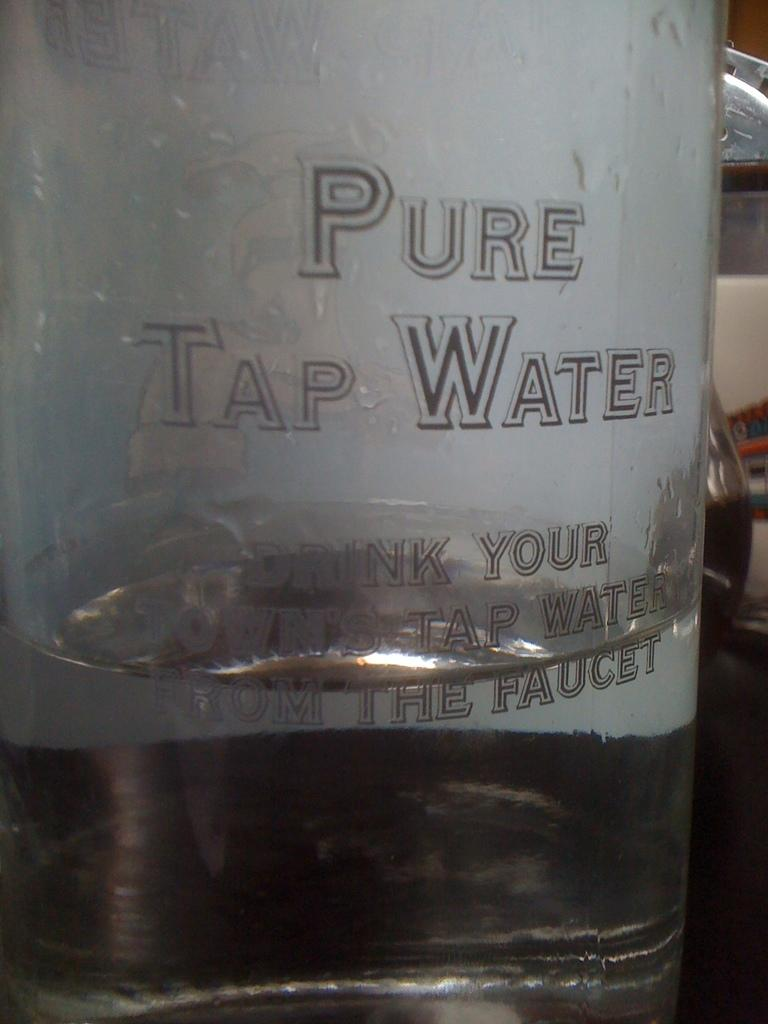What object can be seen in the image? There is a bottle in the image. What is inside the bottle? There is water in the bottle. How many yaks are present at the party in the image? There are no yaks or parties present in the image; it only features a bottle with water. 